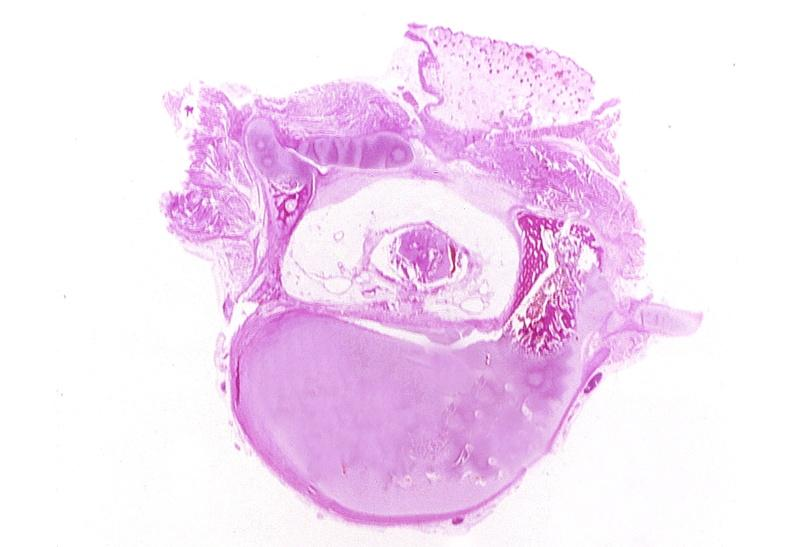what does this image show?
Answer the question using a single word or phrase. Neural tube defect 